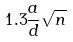Convert formula to latex. <formula><loc_0><loc_0><loc_500><loc_500>1 . 3 \frac { a } { d } \sqrt { n }</formula> 